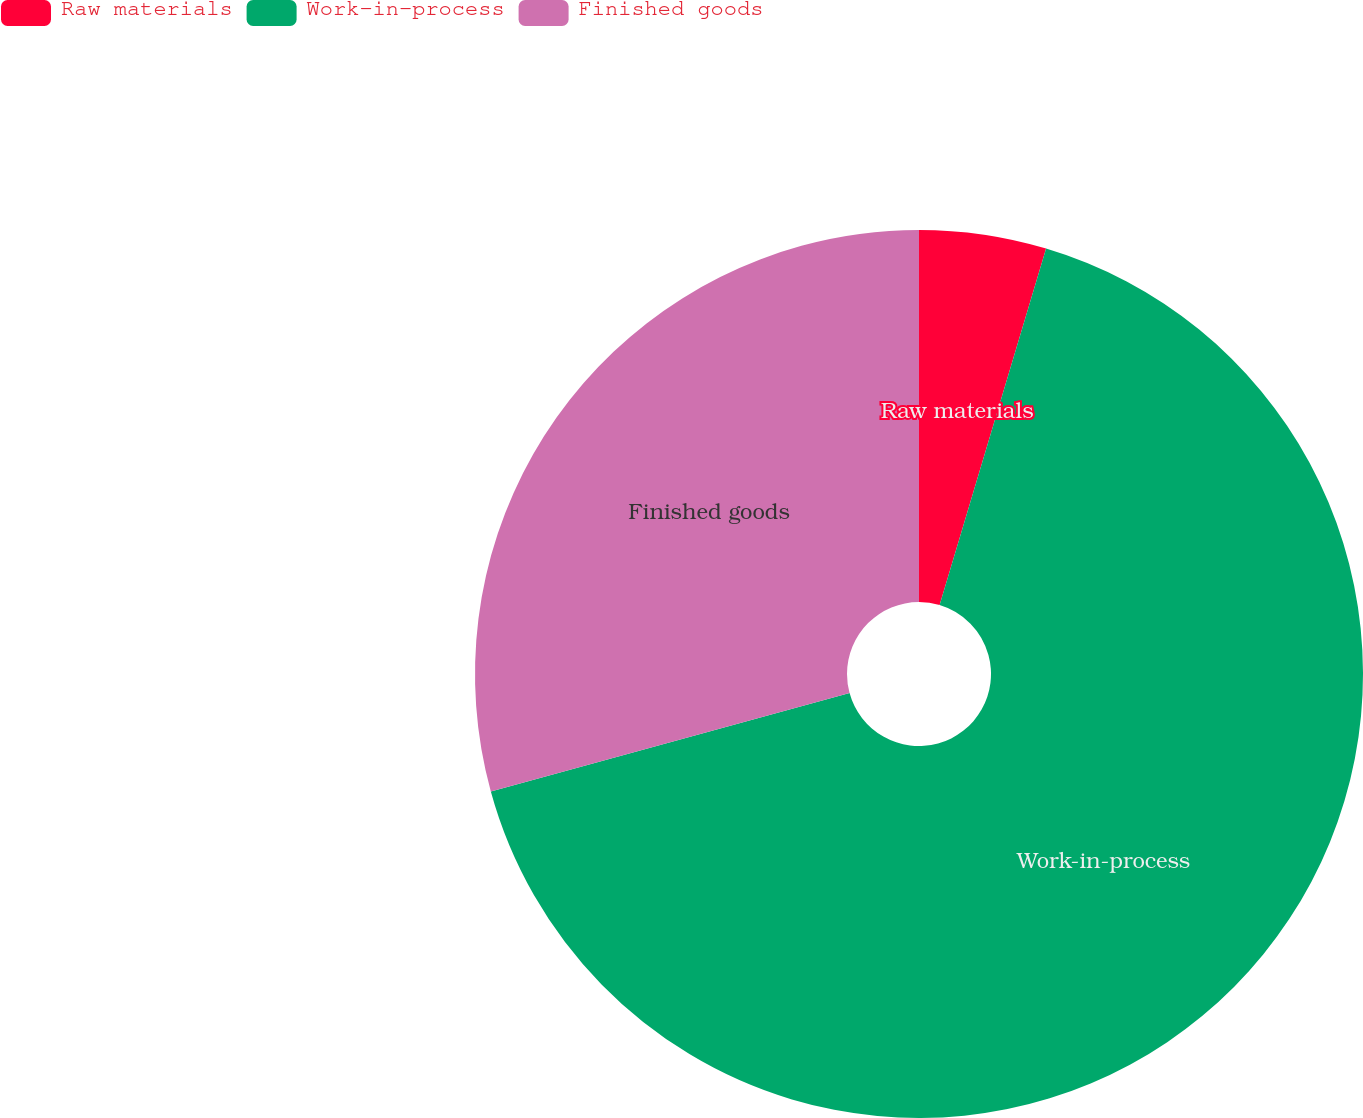Convert chart to OTSL. <chart><loc_0><loc_0><loc_500><loc_500><pie_chart><fcel>Raw materials<fcel>Work-in-process<fcel>Finished goods<nl><fcel>4.62%<fcel>66.11%<fcel>29.26%<nl></chart> 